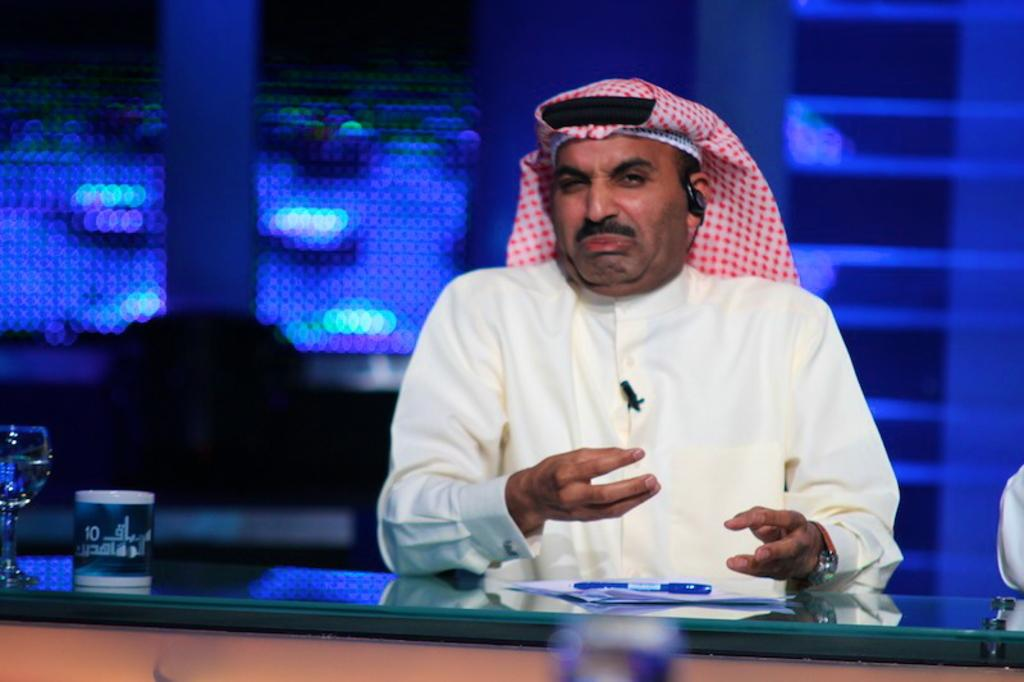What is the main subject in the middle of the image? There is a man sitting in the middle of the image. What is located at the bottom of the image? There is a table at the bottom of the image. What items can be seen on the table? There is a paper and a pen on the table. What is located on the bottom left side of the image? There is a glass on the bottom left side of the image. How many horses are present in the image? There are no horses present in the image. What type of sail is visible in the image? There is no sail present in the image. 